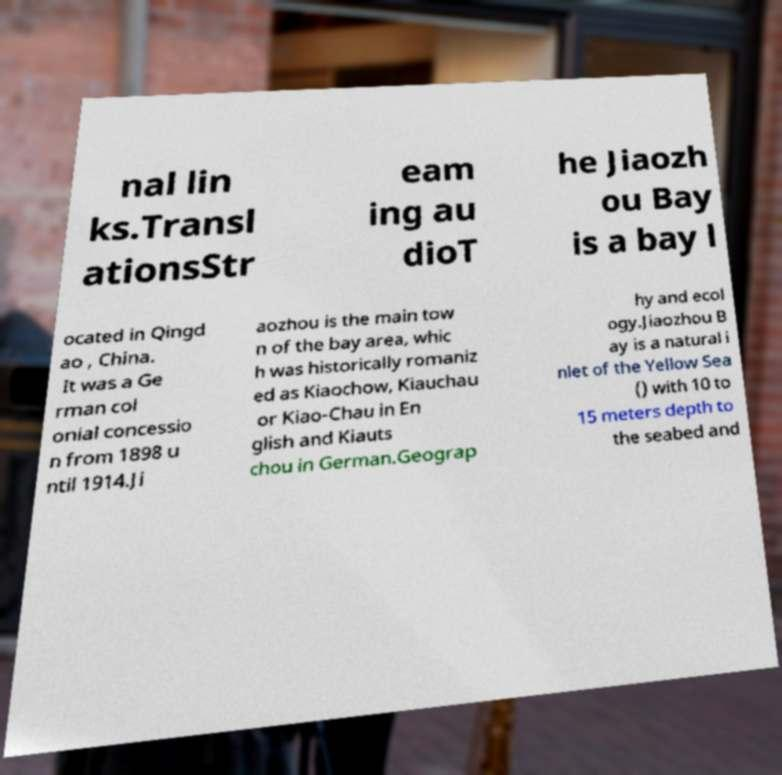For documentation purposes, I need the text within this image transcribed. Could you provide that? nal lin ks.Transl ationsStr eam ing au dioT he Jiaozh ou Bay is a bay l ocated in Qingd ao , China. It was a Ge rman col onial concessio n from 1898 u ntil 1914.Ji aozhou is the main tow n of the bay area, whic h was historically romaniz ed as Kiaochow, Kiauchau or Kiao-Chau in En glish and Kiauts chou in German.Geograp hy and ecol ogy.Jiaozhou B ay is a natural i nlet of the Yellow Sea () with 10 to 15 meters depth to the seabed and 